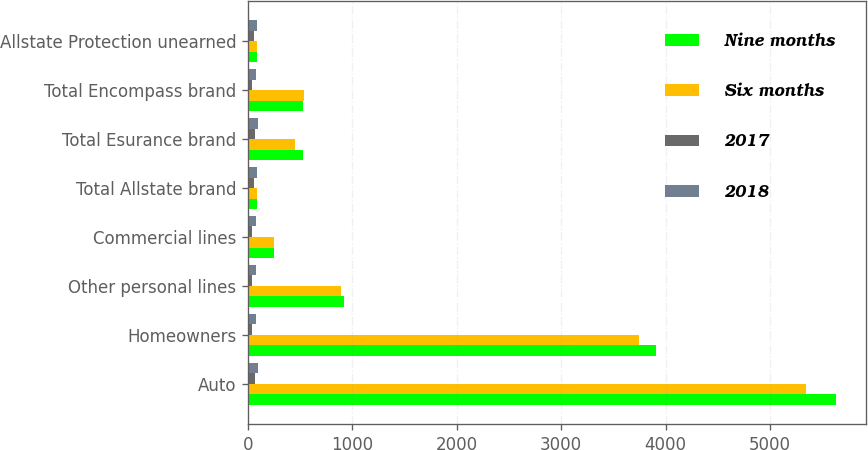Convert chart to OTSL. <chart><loc_0><loc_0><loc_500><loc_500><stacked_bar_chart><ecel><fcel>Auto<fcel>Homeowners<fcel>Other personal lines<fcel>Commercial lines<fcel>Total Allstate brand<fcel>Total Esurance brand<fcel>Total Encompass brand<fcel>Allstate Protection unearned<nl><fcel>Nine months<fcel>5635<fcel>3908<fcel>917<fcel>250<fcel>91.65<fcel>526<fcel>529<fcel>91.65<nl><fcel>Six months<fcel>5344<fcel>3745<fcel>895<fcel>246<fcel>91.65<fcel>448<fcel>535<fcel>91.65<nl><fcel>2017<fcel>71.1<fcel>43.3<fcel>43.4<fcel>44<fcel>58.1<fcel>71.1<fcel>43.8<fcel>58.1<nl><fcel>2018<fcel>96.6<fcel>75.4<fcel>75.3<fcel>75.2<fcel>86.7<fcel>96.6<fcel>75.7<fcel>86.6<nl></chart> 